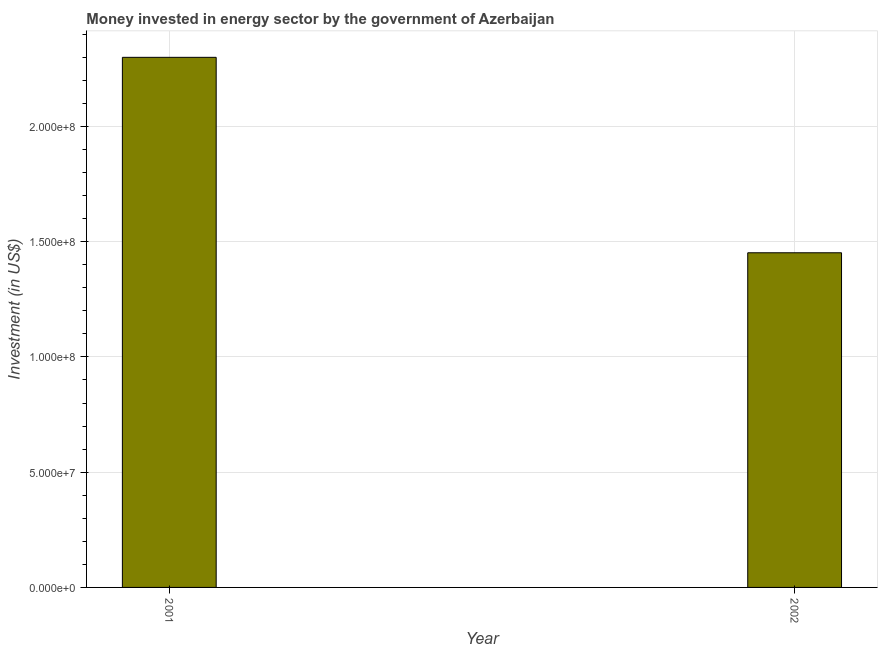What is the title of the graph?
Make the answer very short. Money invested in energy sector by the government of Azerbaijan. What is the label or title of the X-axis?
Keep it short and to the point. Year. What is the label or title of the Y-axis?
Keep it short and to the point. Investment (in US$). What is the investment in energy in 2002?
Your response must be concise. 1.45e+08. Across all years, what is the maximum investment in energy?
Keep it short and to the point. 2.30e+08. Across all years, what is the minimum investment in energy?
Offer a very short reply. 1.45e+08. In which year was the investment in energy minimum?
Your answer should be very brief. 2002. What is the sum of the investment in energy?
Your answer should be compact. 3.75e+08. What is the difference between the investment in energy in 2001 and 2002?
Make the answer very short. 8.48e+07. What is the average investment in energy per year?
Keep it short and to the point. 1.88e+08. What is the median investment in energy?
Give a very brief answer. 1.88e+08. What is the ratio of the investment in energy in 2001 to that in 2002?
Your response must be concise. 1.58. In how many years, is the investment in energy greater than the average investment in energy taken over all years?
Provide a short and direct response. 1. Are all the bars in the graph horizontal?
Provide a short and direct response. No. How many years are there in the graph?
Your answer should be compact. 2. What is the difference between two consecutive major ticks on the Y-axis?
Your answer should be compact. 5.00e+07. What is the Investment (in US$) of 2001?
Your answer should be very brief. 2.30e+08. What is the Investment (in US$) in 2002?
Your response must be concise. 1.45e+08. What is the difference between the Investment (in US$) in 2001 and 2002?
Provide a short and direct response. 8.48e+07. What is the ratio of the Investment (in US$) in 2001 to that in 2002?
Provide a short and direct response. 1.58. 